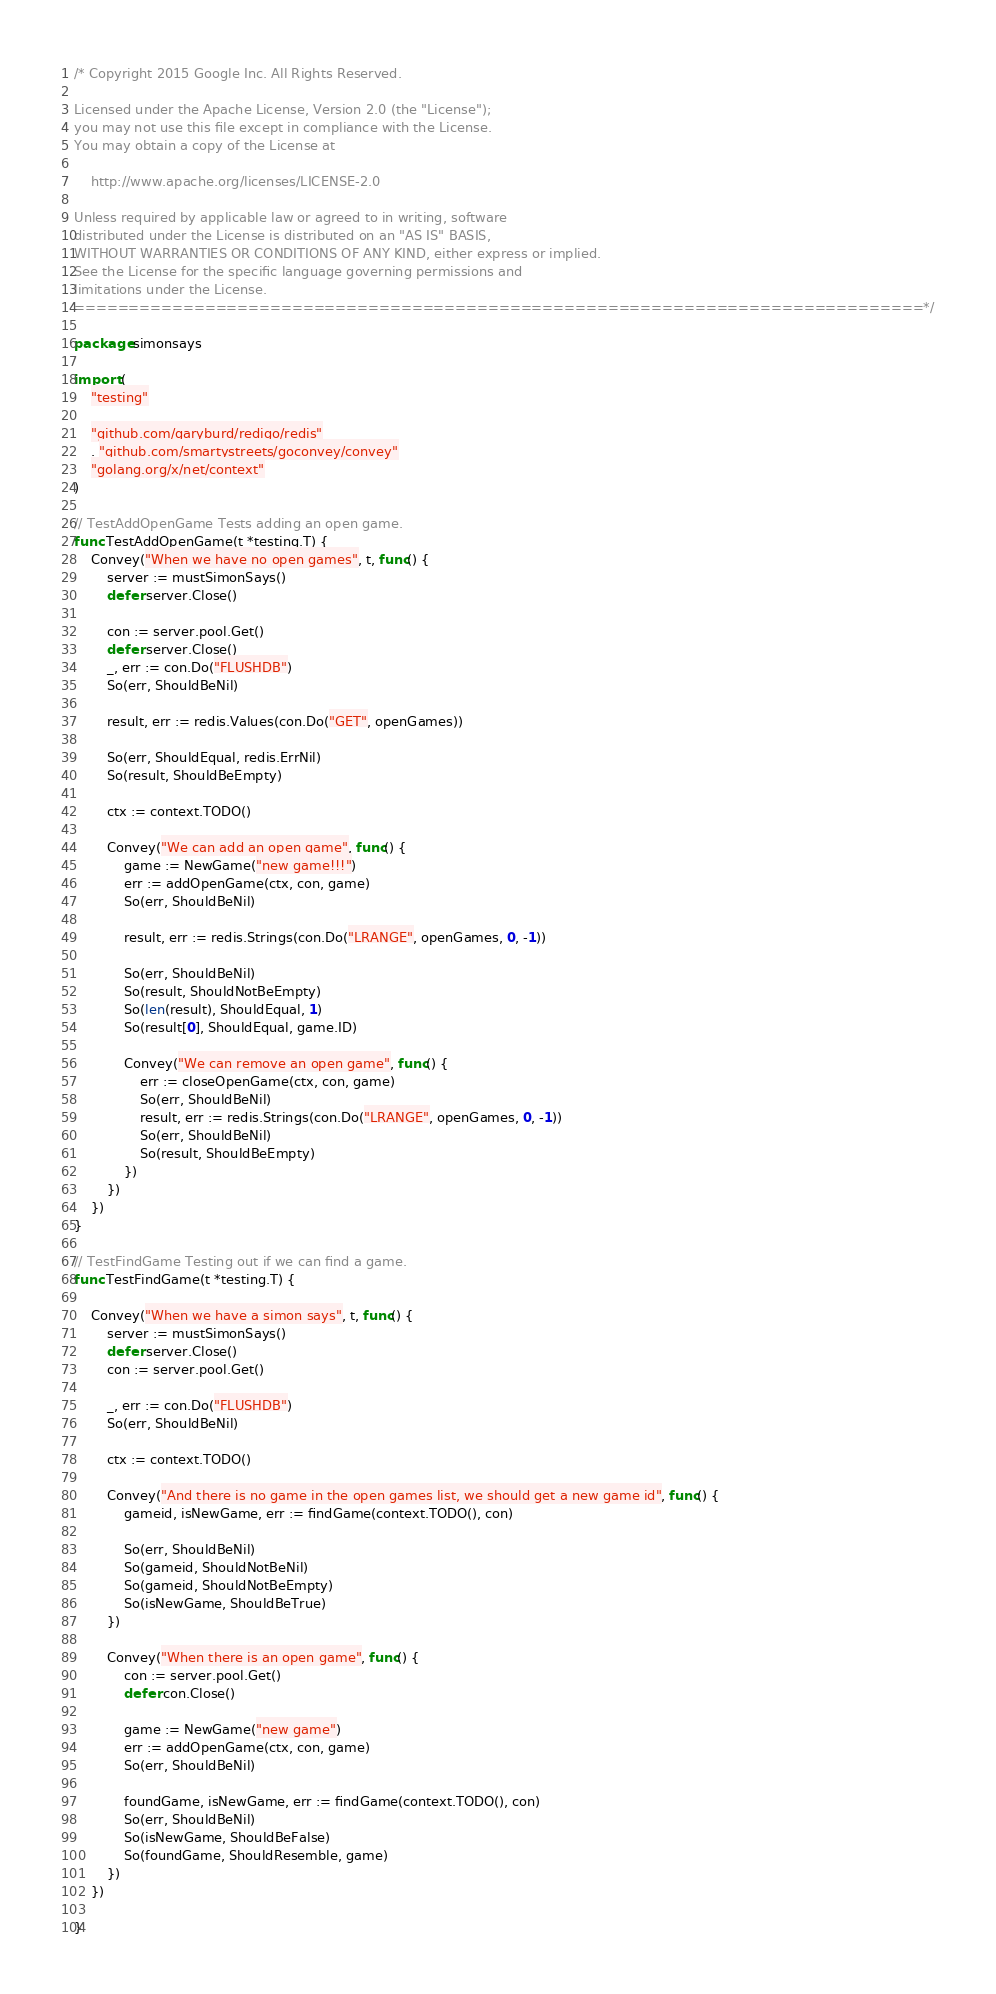Convert code to text. <code><loc_0><loc_0><loc_500><loc_500><_Go_>/* Copyright 2015 Google Inc. All Rights Reserved.

Licensed under the Apache License, Version 2.0 (the "License");
you may not use this file except in compliance with the License.
You may obtain a copy of the License at

    http://www.apache.org/licenses/LICENSE-2.0

Unless required by applicable law or agreed to in writing, software
distributed under the License is distributed on an "AS IS" BASIS,
WITHOUT WARRANTIES OR CONDITIONS OF ANY KIND, either express or implied.
See the License for the specific language governing permissions and
limitations under the License.
==============================================================================*/

package simonsays

import (
	"testing"

	"github.com/garyburd/redigo/redis"
	. "github.com/smartystreets/goconvey/convey"
	"golang.org/x/net/context"
)

// TestAddOpenGame Tests adding an open game.
func TestAddOpenGame(t *testing.T) {
	Convey("When we have no open games", t, func() {
		server := mustSimonSays()
		defer server.Close()

		con := server.pool.Get()
		defer server.Close()
		_, err := con.Do("FLUSHDB")
		So(err, ShouldBeNil)

		result, err := redis.Values(con.Do("GET", openGames))

		So(err, ShouldEqual, redis.ErrNil)
		So(result, ShouldBeEmpty)

		ctx := context.TODO()

		Convey("We can add an open game", func() {
			game := NewGame("new game!!!")
			err := addOpenGame(ctx, con, game)
			So(err, ShouldBeNil)

			result, err := redis.Strings(con.Do("LRANGE", openGames, 0, -1))

			So(err, ShouldBeNil)
			So(result, ShouldNotBeEmpty)
			So(len(result), ShouldEqual, 1)
			So(result[0], ShouldEqual, game.ID)

			Convey("We can remove an open game", func() {
				err := closeOpenGame(ctx, con, game)
				So(err, ShouldBeNil)
				result, err := redis.Strings(con.Do("LRANGE", openGames, 0, -1))
				So(err, ShouldBeNil)
				So(result, ShouldBeEmpty)
			})
		})
	})
}

// TestFindGame Testing out if we can find a game.
func TestFindGame(t *testing.T) {

	Convey("When we have a simon says", t, func() {
		server := mustSimonSays()
		defer server.Close()
		con := server.pool.Get()

		_, err := con.Do("FLUSHDB")
		So(err, ShouldBeNil)

		ctx := context.TODO()

		Convey("And there is no game in the open games list, we should get a new game id", func() {
			gameid, isNewGame, err := findGame(context.TODO(), con)

			So(err, ShouldBeNil)
			So(gameid, ShouldNotBeNil)
			So(gameid, ShouldNotBeEmpty)
			So(isNewGame, ShouldBeTrue)
		})

		Convey("When there is an open game", func() {
			con := server.pool.Get()
			defer con.Close()

			game := NewGame("new game")
			err := addOpenGame(ctx, con, game)
			So(err, ShouldBeNil)

			foundGame, isNewGame, err := findGame(context.TODO(), con)
			So(err, ShouldBeNil)
			So(isNewGame, ShouldBeFalse)
			So(foundGame, ShouldResemble, game)
		})
	})

}
</code> 